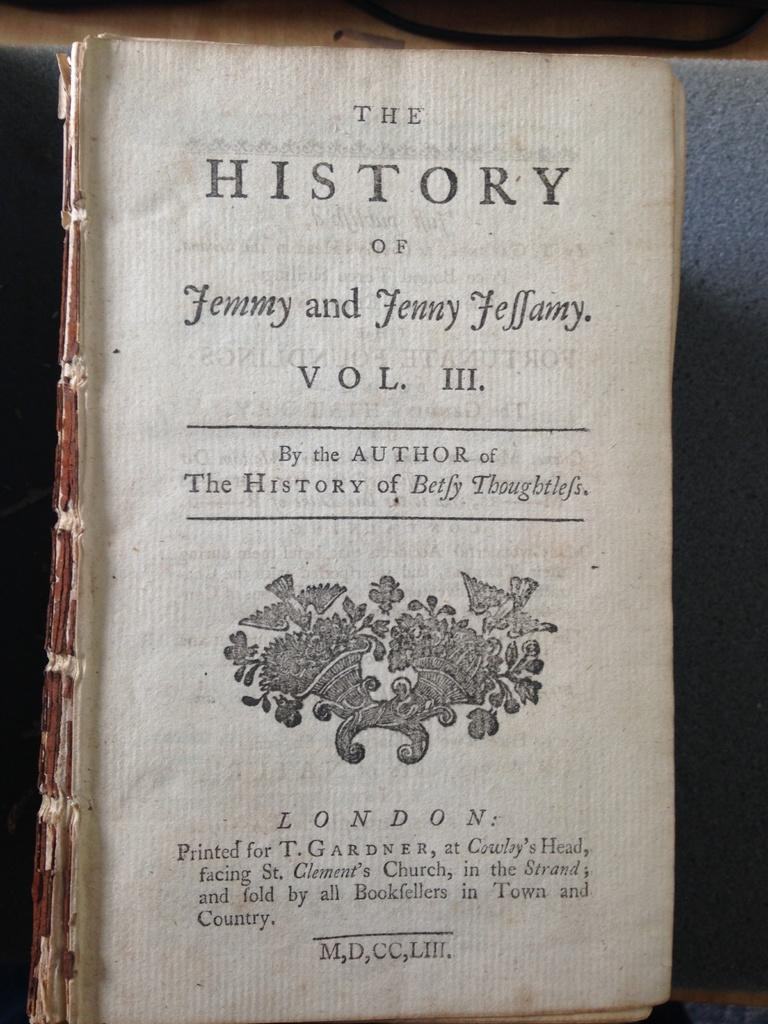<image>
Give a short and clear explanation of the subsequent image. The third volume of a History book missing its cover. 